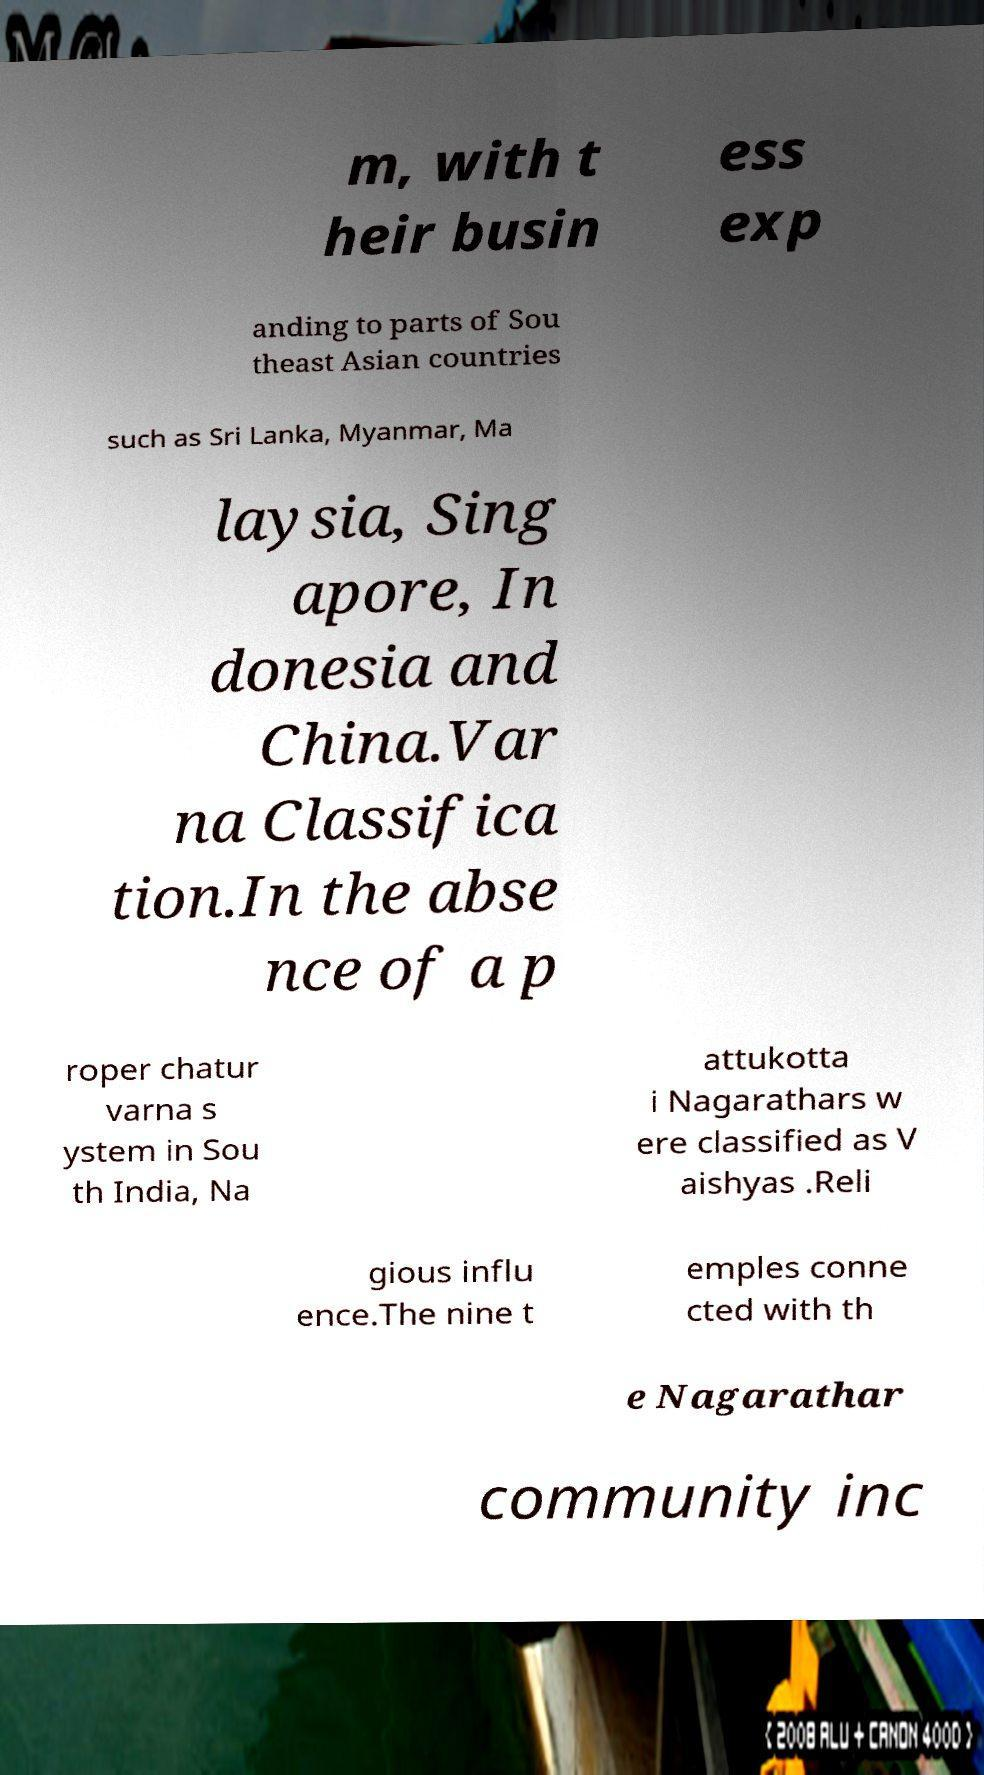Could you assist in decoding the text presented in this image and type it out clearly? m, with t heir busin ess exp anding to parts of Sou theast Asian countries such as Sri Lanka, Myanmar, Ma laysia, Sing apore, In donesia and China.Var na Classifica tion.In the abse nce of a p roper chatur varna s ystem in Sou th India, Na attukotta i Nagarathars w ere classified as V aishyas .Reli gious influ ence.The nine t emples conne cted with th e Nagarathar community inc 